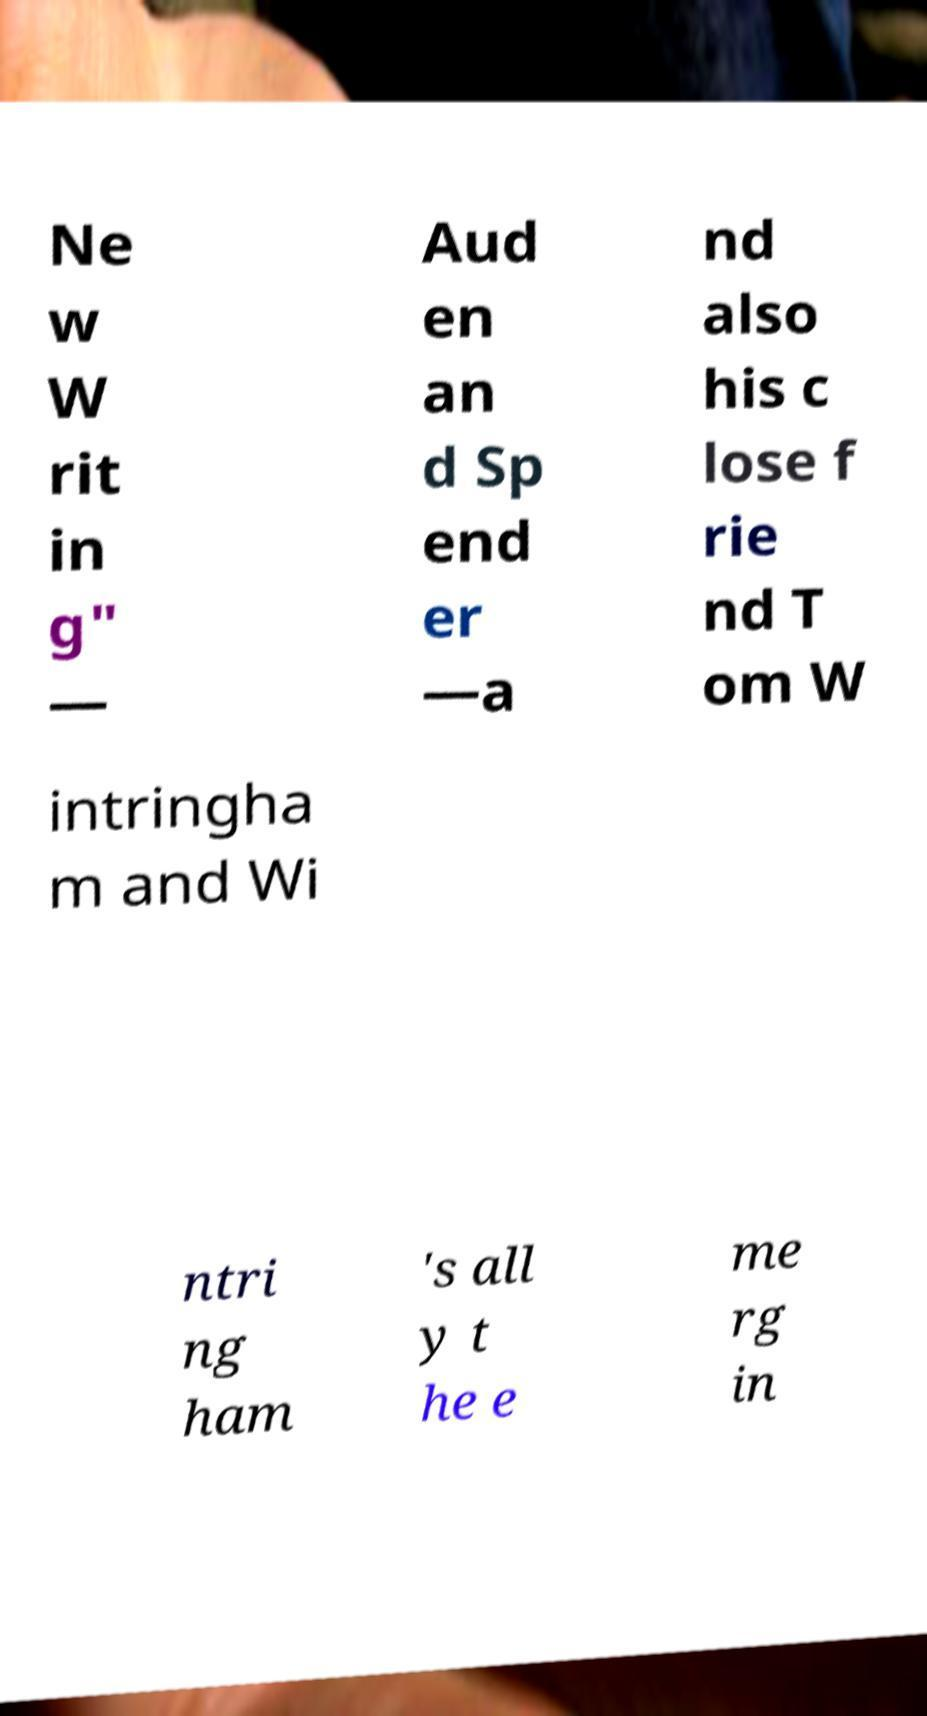What messages or text are displayed in this image? I need them in a readable, typed format. Ne w W rit in g" — Aud en an d Sp end er —a nd also his c lose f rie nd T om W intringha m and Wi ntri ng ham 's all y t he e me rg in 